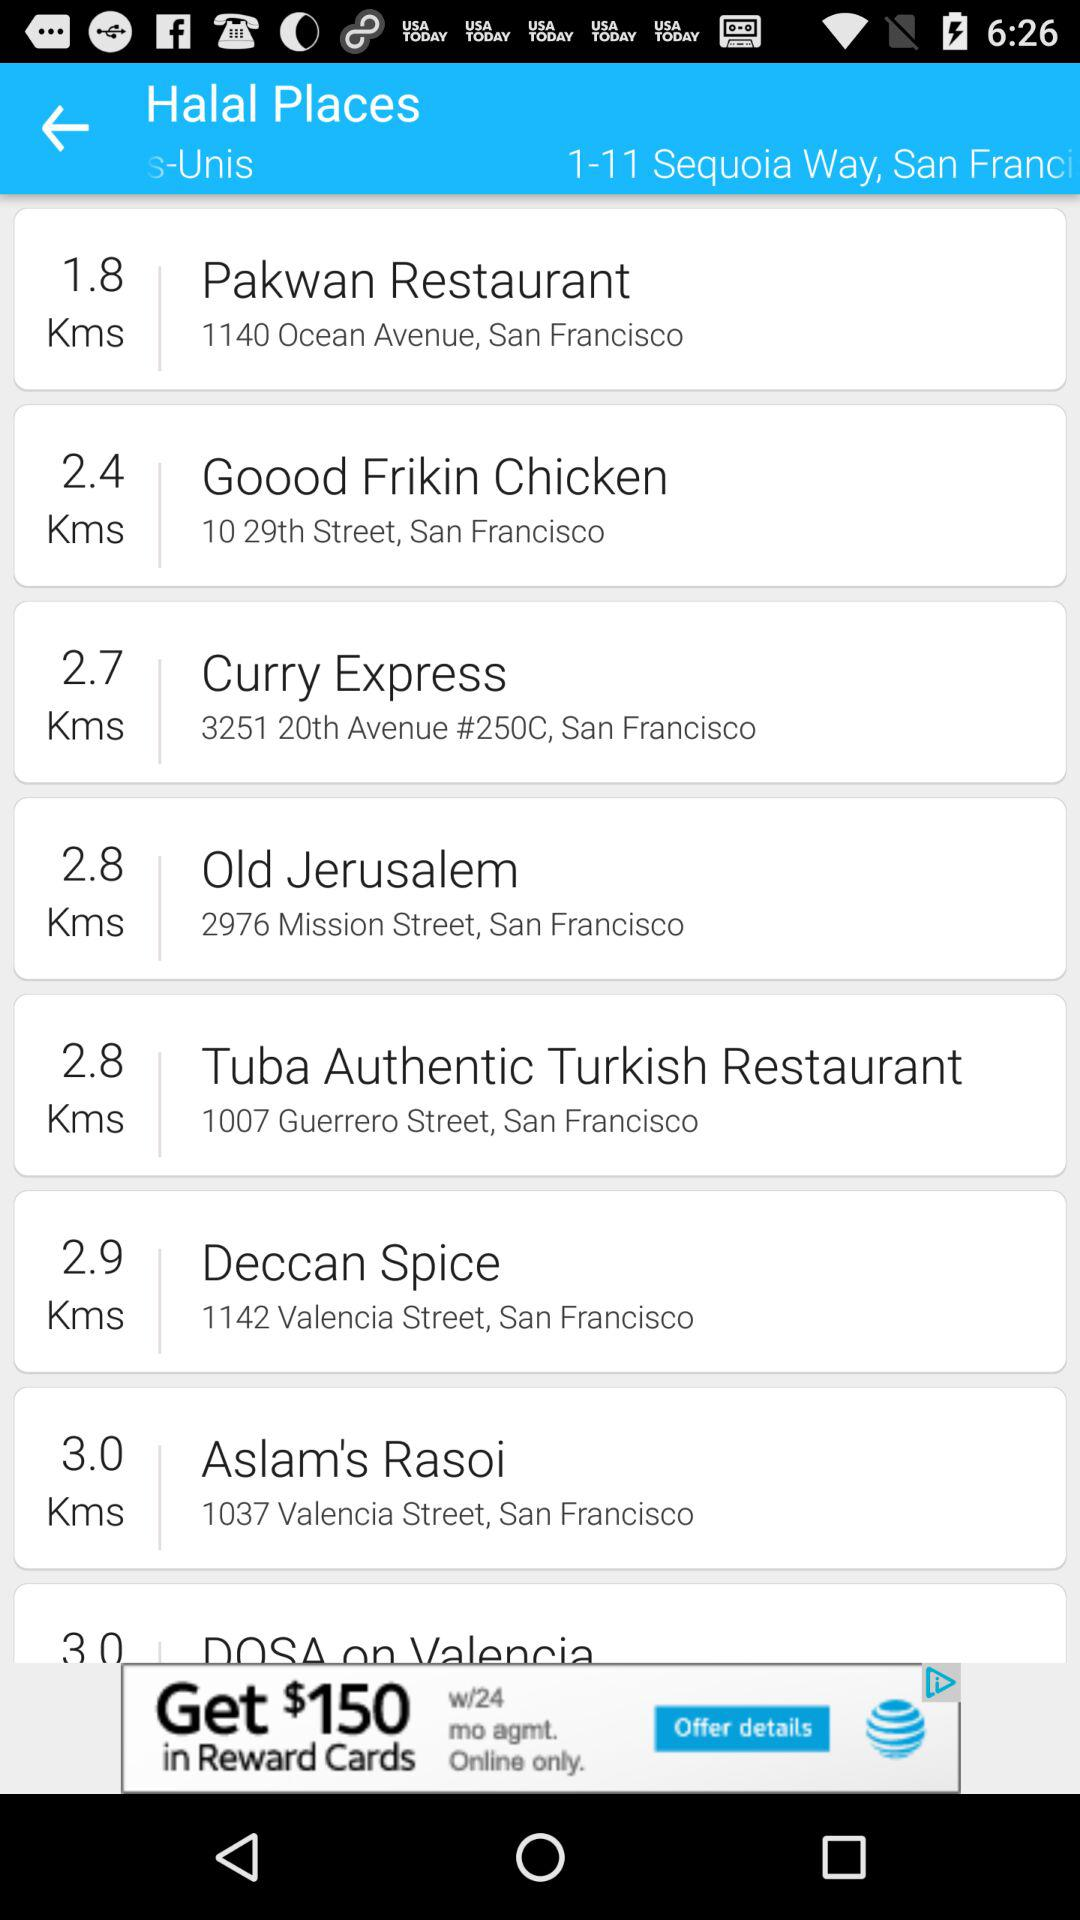What is the address of the Old Jerusalem? The address is 2976 Mission Street, San Francisco. 